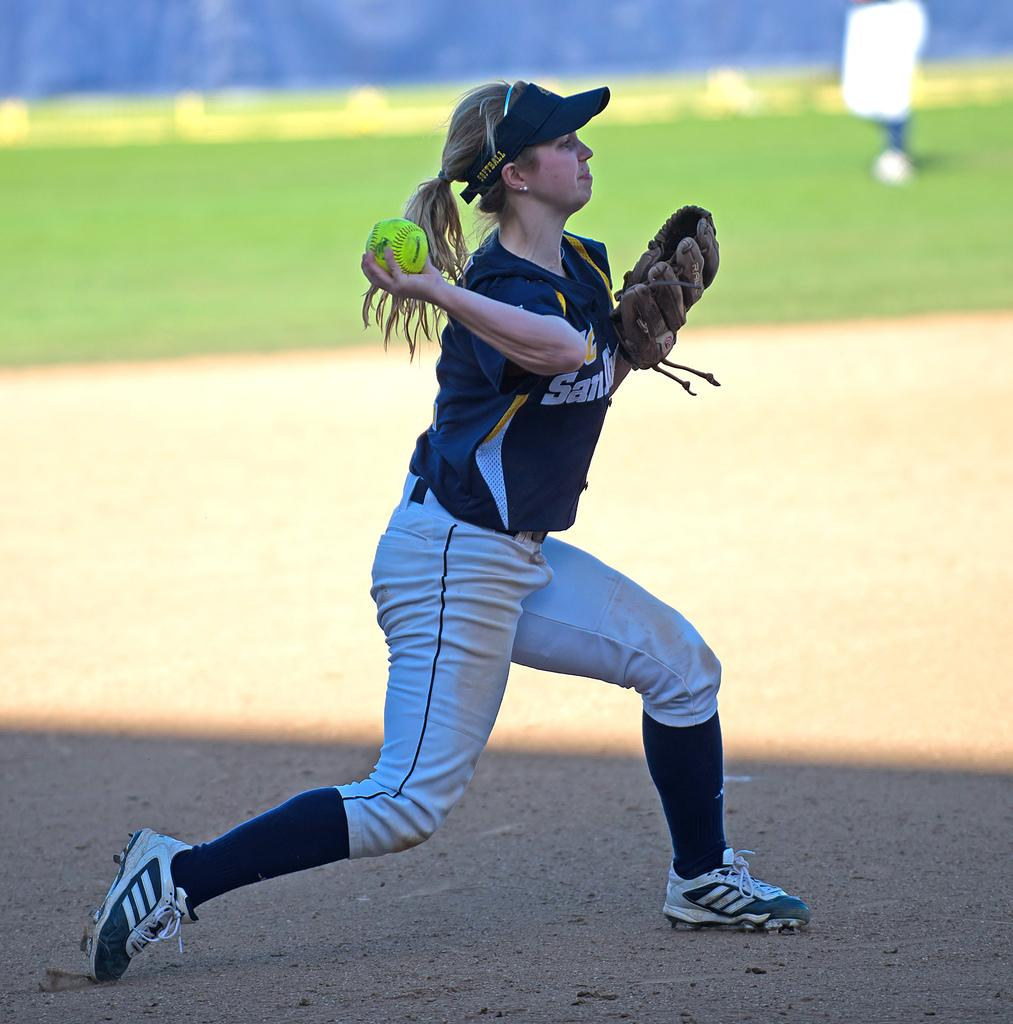<image>
Describe the image concisely. The pitcher of UC San Diego's softball team is getting ready to throw. 